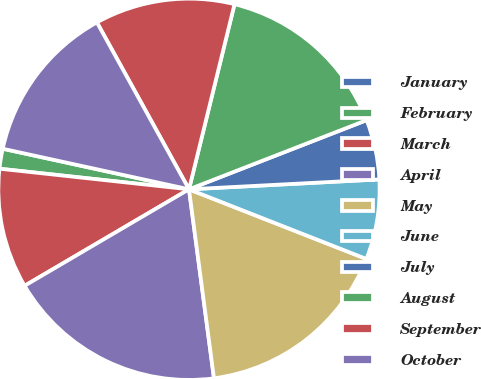Convert chart. <chart><loc_0><loc_0><loc_500><loc_500><pie_chart><fcel>January<fcel>February<fcel>March<fcel>April<fcel>May<fcel>June<fcel>July<fcel>August<fcel>September<fcel>October<nl><fcel>0.0%<fcel>1.69%<fcel>10.17%<fcel>18.64%<fcel>16.95%<fcel>6.78%<fcel>5.08%<fcel>15.25%<fcel>11.86%<fcel>13.56%<nl></chart> 